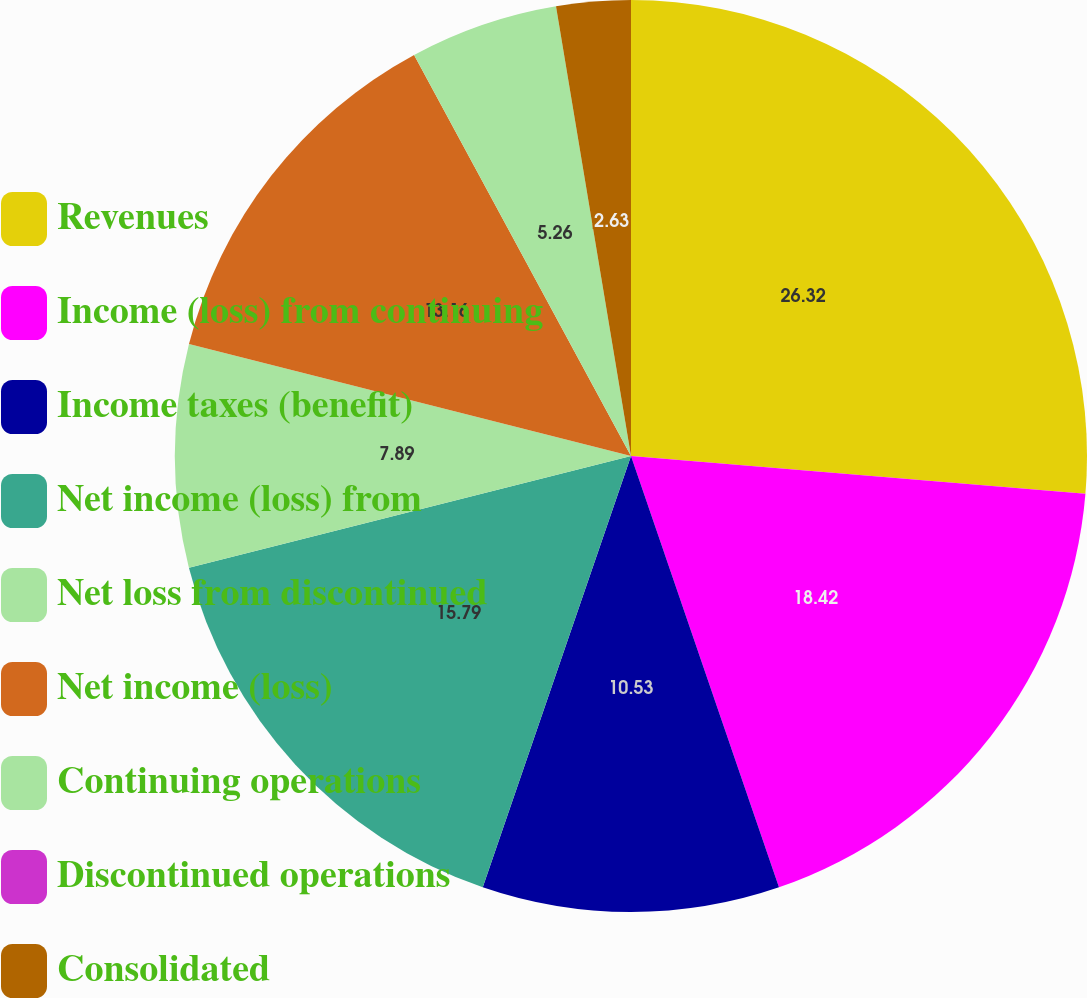Convert chart to OTSL. <chart><loc_0><loc_0><loc_500><loc_500><pie_chart><fcel>Revenues<fcel>Income (loss) from continuing<fcel>Income taxes (benefit)<fcel>Net income (loss) from<fcel>Net loss from discontinued<fcel>Net income (loss)<fcel>Continuing operations<fcel>Discontinued operations<fcel>Consolidated<nl><fcel>26.32%<fcel>18.42%<fcel>10.53%<fcel>15.79%<fcel>7.89%<fcel>13.16%<fcel>5.26%<fcel>0.0%<fcel>2.63%<nl></chart> 